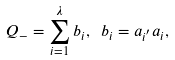<formula> <loc_0><loc_0><loc_500><loc_500>Q _ { - } = \sum _ { i = 1 } ^ { \lambda } b _ { i } , \ b _ { i } = a _ { i ^ { ^ { \prime } } } a _ { i } ,</formula> 